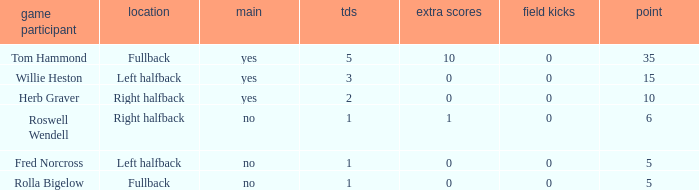What is the lowest number of field goals for a player with 3 touchdowns? 0.0. 